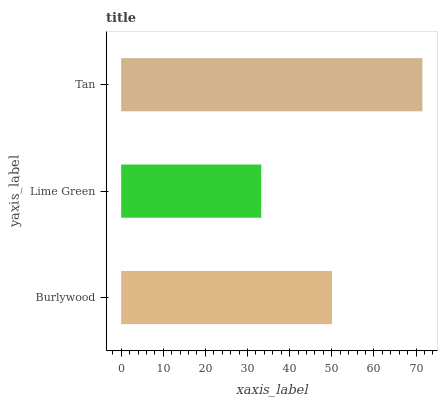Is Lime Green the minimum?
Answer yes or no. Yes. Is Tan the maximum?
Answer yes or no. Yes. Is Tan the minimum?
Answer yes or no. No. Is Lime Green the maximum?
Answer yes or no. No. Is Tan greater than Lime Green?
Answer yes or no. Yes. Is Lime Green less than Tan?
Answer yes or no. Yes. Is Lime Green greater than Tan?
Answer yes or no. No. Is Tan less than Lime Green?
Answer yes or no. No. Is Burlywood the high median?
Answer yes or no. Yes. Is Burlywood the low median?
Answer yes or no. Yes. Is Lime Green the high median?
Answer yes or no. No. Is Tan the low median?
Answer yes or no. No. 